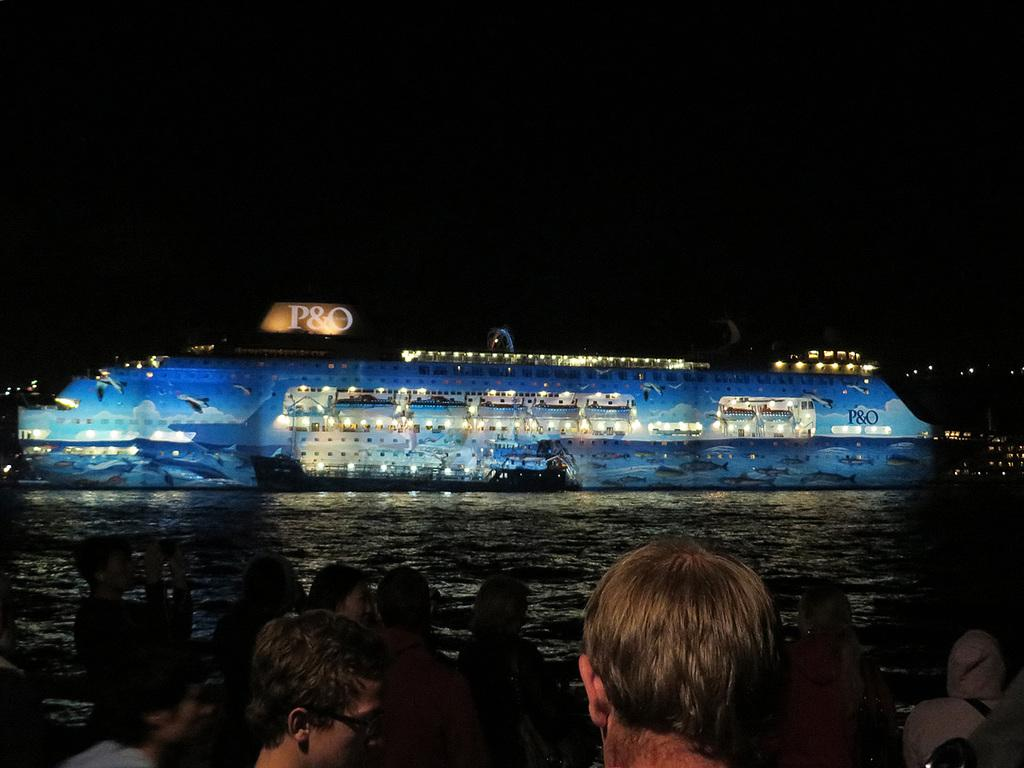How many people are in the image? There is a group of people in the image. What are the people standing on in the image? The people are standing on a path in the image. What can be seen in front of the people in the image? There is a boat on the water in front of the people in the image. What is the color of the background in the image? The background of the image is dark. What type of bed can be seen in the image? There is no bed present in the image; it features a group of people standing on a path with a boat on the water in front of them. Can you tell me how many people are wearing underwear in the image? There is no information about the clothing of the people in the image, so it cannot be determined how many are wearing underwear. 